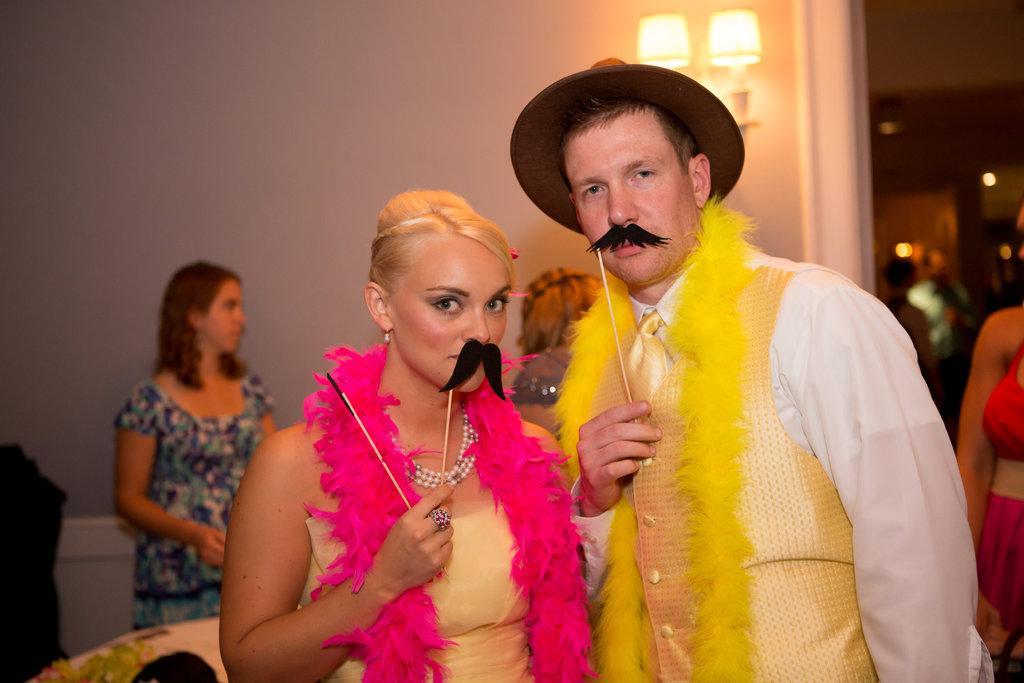In one or two sentences, can you explain what this image depicts? In this image we can see a few people, two of them are holding artificial mustaches, and sticks, behind them, there are lights, and the wall, the background is blurred. 